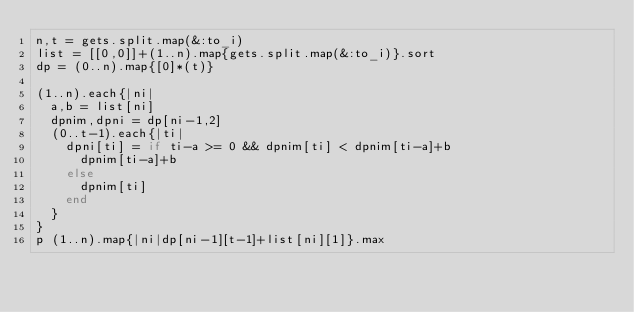<code> <loc_0><loc_0><loc_500><loc_500><_Ruby_>n,t = gets.split.map(&:to_i)
list = [[0,0]]+(1..n).map{gets.split.map(&:to_i)}.sort
dp = (0..n).map{[0]*(t)}

(1..n).each{|ni|
  a,b = list[ni]
  dpnim,dpni = dp[ni-1,2]
  (0..t-1).each{|ti|
    dpni[ti] = if ti-a >= 0 && dpnim[ti] < dpnim[ti-a]+b
      dpnim[ti-a]+b
    else
      dpnim[ti]
    end
  }
}
p (1..n).map{|ni|dp[ni-1][t-1]+list[ni][1]}.max</code> 